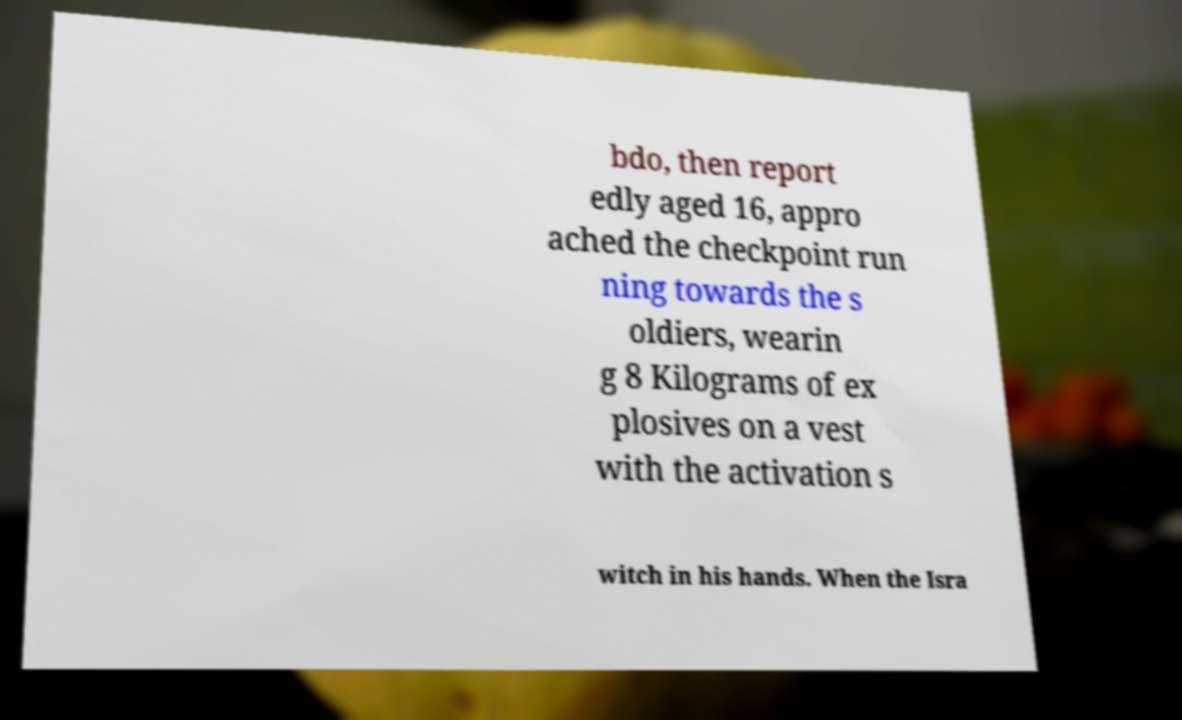Can you read and provide the text displayed in the image?This photo seems to have some interesting text. Can you extract and type it out for me? bdo, then report edly aged 16, appro ached the checkpoint run ning towards the s oldiers, wearin g 8 Kilograms of ex plosives on a vest with the activation s witch in his hands. When the Isra 